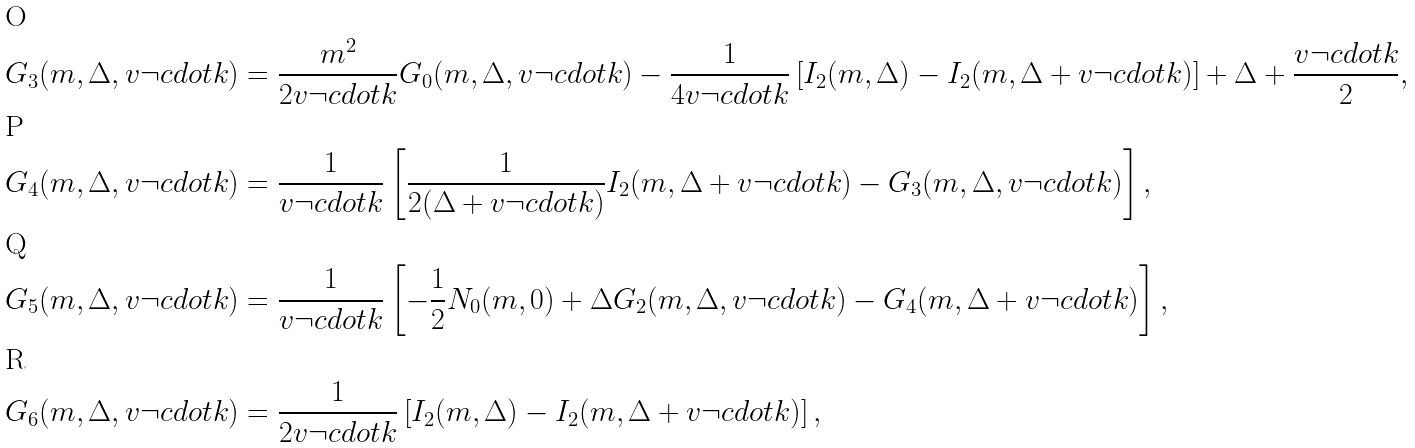<formula> <loc_0><loc_0><loc_500><loc_500>G _ { 3 } ( m , \Delta , v \neg c d o t k ) & = \frac { m ^ { 2 } } { 2 v \neg c d o t k } G _ { 0 } ( m , \Delta , v \neg c d o t k ) - \frac { 1 } { 4 v \neg c d o t k } \left [ I _ { 2 } ( m , \Delta ) - I _ { 2 } ( m , \Delta + v \neg c d o t k ) \right ] + \Delta + \frac { v \neg c d o t k } { 2 } , \\ G _ { 4 } ( m , \Delta , v \neg c d o t k ) & = \frac { 1 } { v \neg c d o t k } \left [ \frac { 1 } { 2 ( \Delta + v \neg c d o t k ) } I _ { 2 } ( m , \Delta + v \neg c d o t k ) - G _ { 3 } ( m , \Delta , v \neg c d o t k ) \right ] , \\ G _ { 5 } ( m , \Delta , v \neg c d o t k ) & = \frac { 1 } { v \neg c d o t k } \left [ - \frac { 1 } { 2 } N _ { 0 } ( m , 0 ) + \Delta G _ { 2 } ( m , \Delta , v \neg c d o t k ) - G _ { 4 } ( m , \Delta + v \neg c d o t k ) \right ] , \\ G _ { 6 } ( m , \Delta , v \neg c d o t k ) & = \frac { 1 } { 2 v \neg c d o t k } \left [ I _ { 2 } ( m , \Delta ) - I _ { 2 } ( m , \Delta + v \neg c d o t k ) \right ] ,</formula> 